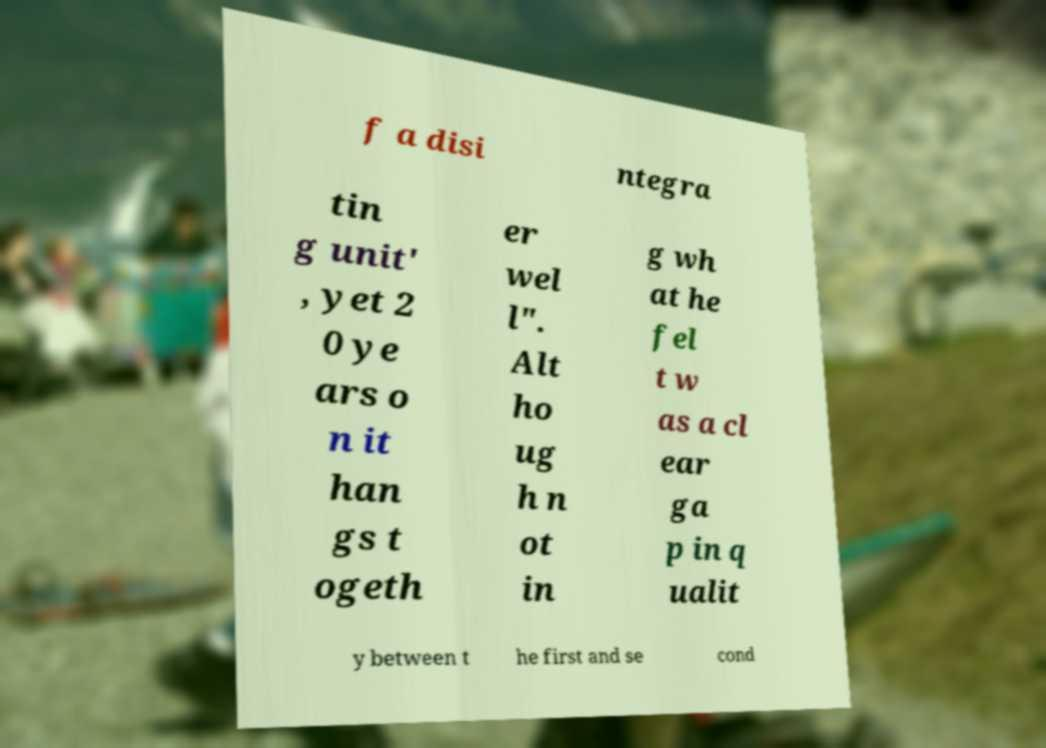Can you read and provide the text displayed in the image?This photo seems to have some interesting text. Can you extract and type it out for me? f a disi ntegra tin g unit' , yet 2 0 ye ars o n it han gs t ogeth er wel l". Alt ho ug h n ot in g wh at he fel t w as a cl ear ga p in q ualit y between t he first and se cond 